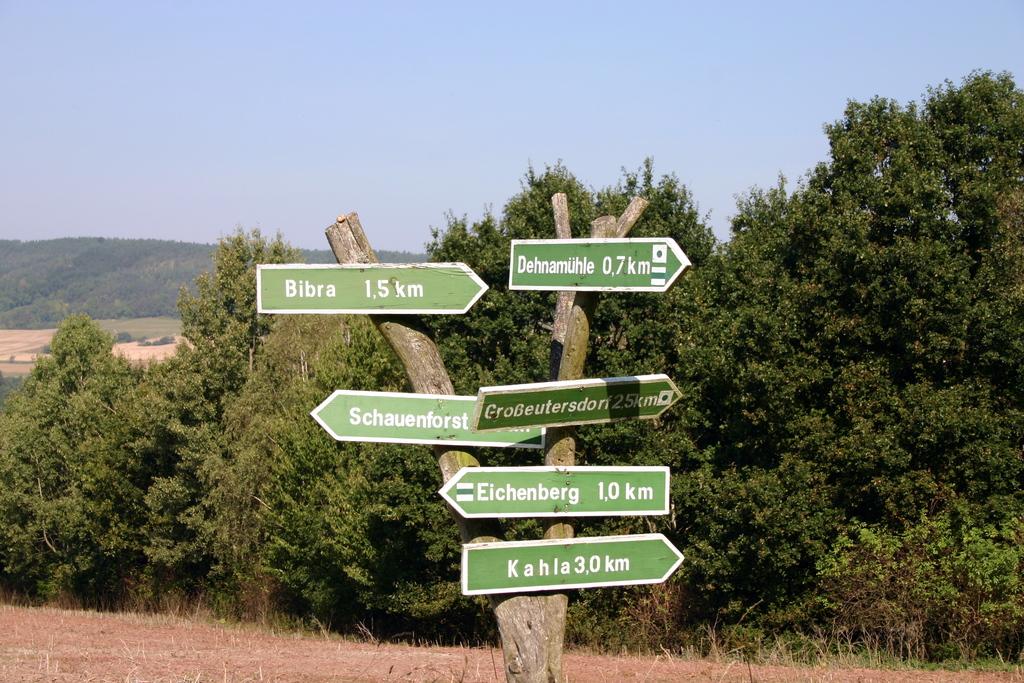How many miles is eichenberg?
Your response must be concise. 1. How far to bibra?
Offer a very short reply. 1.5 km. 